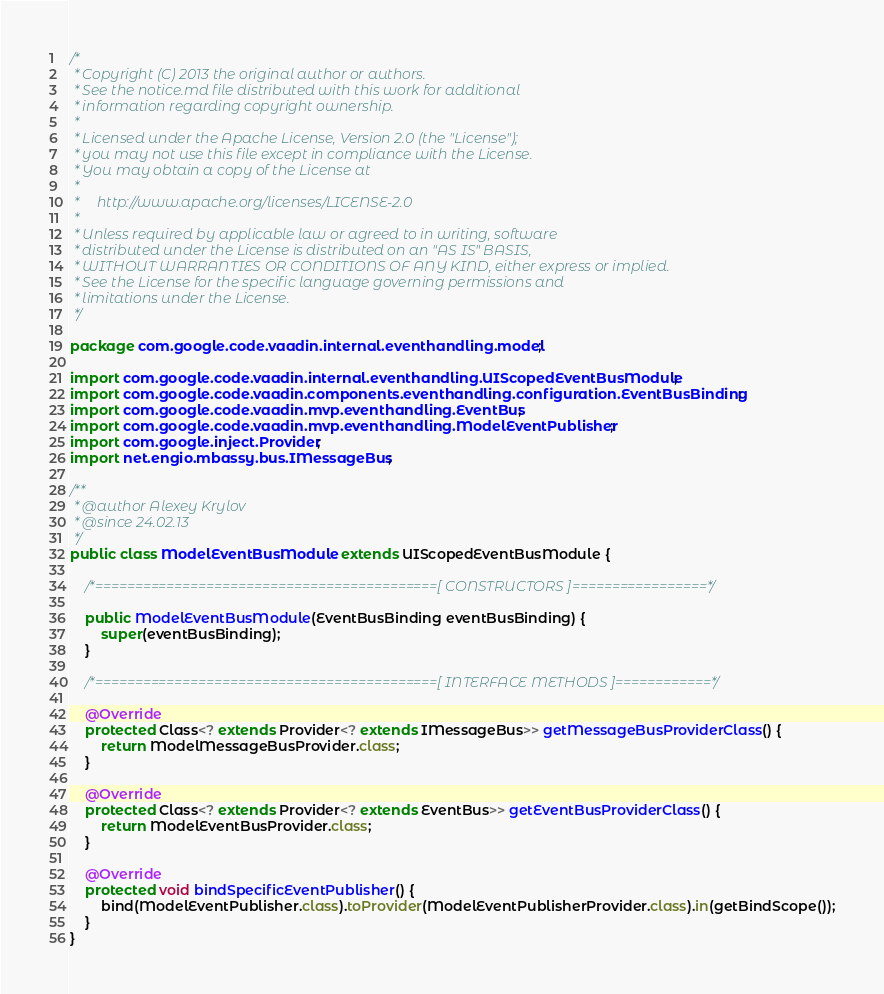<code> <loc_0><loc_0><loc_500><loc_500><_Java_>/*
 * Copyright (C) 2013 the original author or authors.
 * See the notice.md file distributed with this work for additional
 * information regarding copyright ownership.
 *
 * Licensed under the Apache License, Version 2.0 (the "License");
 * you may not use this file except in compliance with the License.
 * You may obtain a copy of the License at
 *
 *     http://www.apache.org/licenses/LICENSE-2.0
 *
 * Unless required by applicable law or agreed to in writing, software
 * distributed under the License is distributed on an "AS IS" BASIS,
 * WITHOUT WARRANTIES OR CONDITIONS OF ANY KIND, either express or implied.
 * See the License for the specific language governing permissions and
 * limitations under the License.
 */

package com.google.code.vaadin.internal.eventhandling.model;

import com.google.code.vaadin.internal.eventhandling.UIScopedEventBusModule;
import com.google.code.vaadin.components.eventhandling.configuration.EventBusBinding;
import com.google.code.vaadin.mvp.eventhandling.EventBus;
import com.google.code.vaadin.mvp.eventhandling.ModelEventPublisher;
import com.google.inject.Provider;
import net.engio.mbassy.bus.IMessageBus;

/**
 * @author Alexey Krylov
 * @since 24.02.13
 */
public class ModelEventBusModule extends UIScopedEventBusModule {

	/*===========================================[ CONSTRUCTORS ]=================*/

    public ModelEventBusModule(EventBusBinding eventBusBinding) {
        super(eventBusBinding);
    }

	/*===========================================[ INTERFACE METHODS ]============*/

    @Override
    protected Class<? extends Provider<? extends IMessageBus>> getMessageBusProviderClass() {
        return ModelMessageBusProvider.class;
    }

    @Override
    protected Class<? extends Provider<? extends EventBus>> getEventBusProviderClass() {
        return ModelEventBusProvider.class;
    }

    @Override
    protected void bindSpecificEventPublisher() {
        bind(ModelEventPublisher.class).toProvider(ModelEventPublisherProvider.class).in(getBindScope());
    }
}</code> 